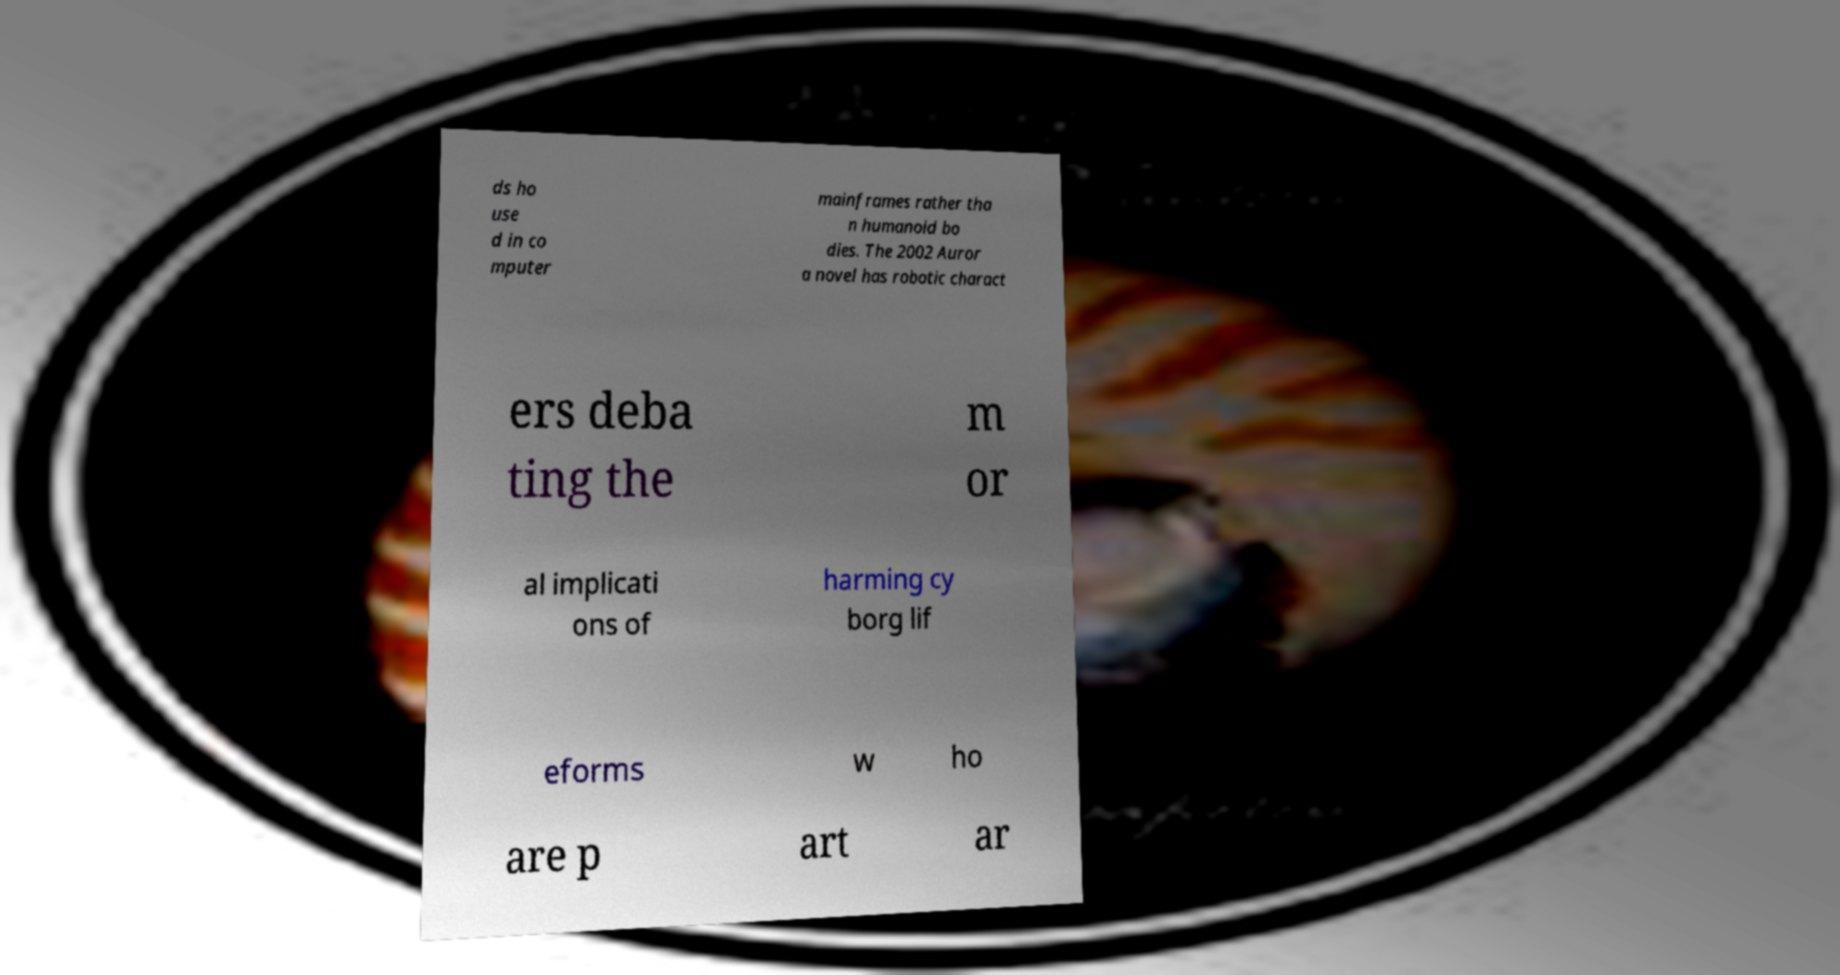Please read and relay the text visible in this image. What does it say? ds ho use d in co mputer mainframes rather tha n humanoid bo dies. The 2002 Auror a novel has robotic charact ers deba ting the m or al implicati ons of harming cy borg lif eforms w ho are p art ar 